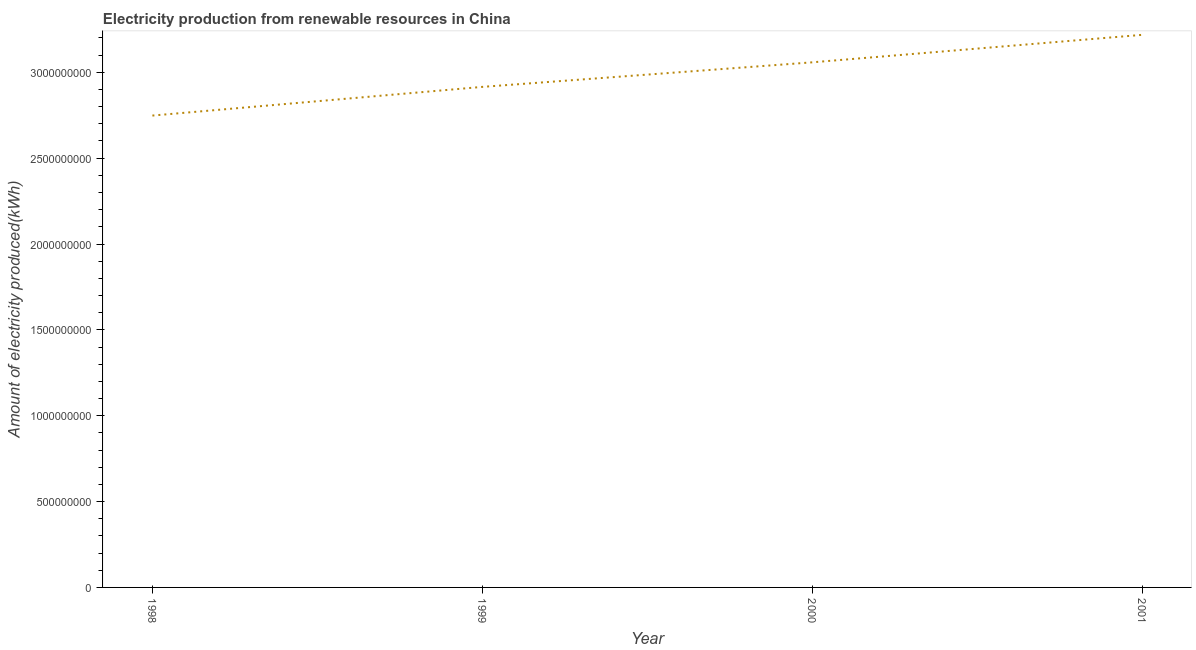What is the amount of electricity produced in 2001?
Ensure brevity in your answer.  3.22e+09. Across all years, what is the maximum amount of electricity produced?
Provide a succinct answer. 3.22e+09. Across all years, what is the minimum amount of electricity produced?
Provide a succinct answer. 2.75e+09. What is the sum of the amount of electricity produced?
Keep it short and to the point. 1.19e+1. What is the difference between the amount of electricity produced in 1999 and 2000?
Your answer should be compact. -1.43e+08. What is the average amount of electricity produced per year?
Offer a terse response. 2.98e+09. What is the median amount of electricity produced?
Your answer should be compact. 2.99e+09. What is the ratio of the amount of electricity produced in 1998 to that in 2001?
Provide a succinct answer. 0.85. Is the amount of electricity produced in 1998 less than that in 2000?
Keep it short and to the point. Yes. What is the difference between the highest and the second highest amount of electricity produced?
Keep it short and to the point. 1.60e+08. What is the difference between the highest and the lowest amount of electricity produced?
Your answer should be compact. 4.70e+08. Does the amount of electricity produced monotonically increase over the years?
Provide a succinct answer. Yes. How many lines are there?
Make the answer very short. 1. What is the difference between two consecutive major ticks on the Y-axis?
Your response must be concise. 5.00e+08. What is the title of the graph?
Your answer should be compact. Electricity production from renewable resources in China. What is the label or title of the Y-axis?
Offer a very short reply. Amount of electricity produced(kWh). What is the Amount of electricity produced(kWh) of 1998?
Make the answer very short. 2.75e+09. What is the Amount of electricity produced(kWh) in 1999?
Keep it short and to the point. 2.92e+09. What is the Amount of electricity produced(kWh) in 2000?
Give a very brief answer. 3.06e+09. What is the Amount of electricity produced(kWh) in 2001?
Provide a succinct answer. 3.22e+09. What is the difference between the Amount of electricity produced(kWh) in 1998 and 1999?
Provide a short and direct response. -1.67e+08. What is the difference between the Amount of electricity produced(kWh) in 1998 and 2000?
Your answer should be compact. -3.10e+08. What is the difference between the Amount of electricity produced(kWh) in 1998 and 2001?
Your response must be concise. -4.70e+08. What is the difference between the Amount of electricity produced(kWh) in 1999 and 2000?
Your answer should be compact. -1.43e+08. What is the difference between the Amount of electricity produced(kWh) in 1999 and 2001?
Ensure brevity in your answer.  -3.03e+08. What is the difference between the Amount of electricity produced(kWh) in 2000 and 2001?
Offer a very short reply. -1.60e+08. What is the ratio of the Amount of electricity produced(kWh) in 1998 to that in 1999?
Keep it short and to the point. 0.94. What is the ratio of the Amount of electricity produced(kWh) in 1998 to that in 2000?
Offer a terse response. 0.9. What is the ratio of the Amount of electricity produced(kWh) in 1998 to that in 2001?
Offer a very short reply. 0.85. What is the ratio of the Amount of electricity produced(kWh) in 1999 to that in 2000?
Keep it short and to the point. 0.95. What is the ratio of the Amount of electricity produced(kWh) in 1999 to that in 2001?
Make the answer very short. 0.91. What is the ratio of the Amount of electricity produced(kWh) in 2000 to that in 2001?
Ensure brevity in your answer.  0.95. 